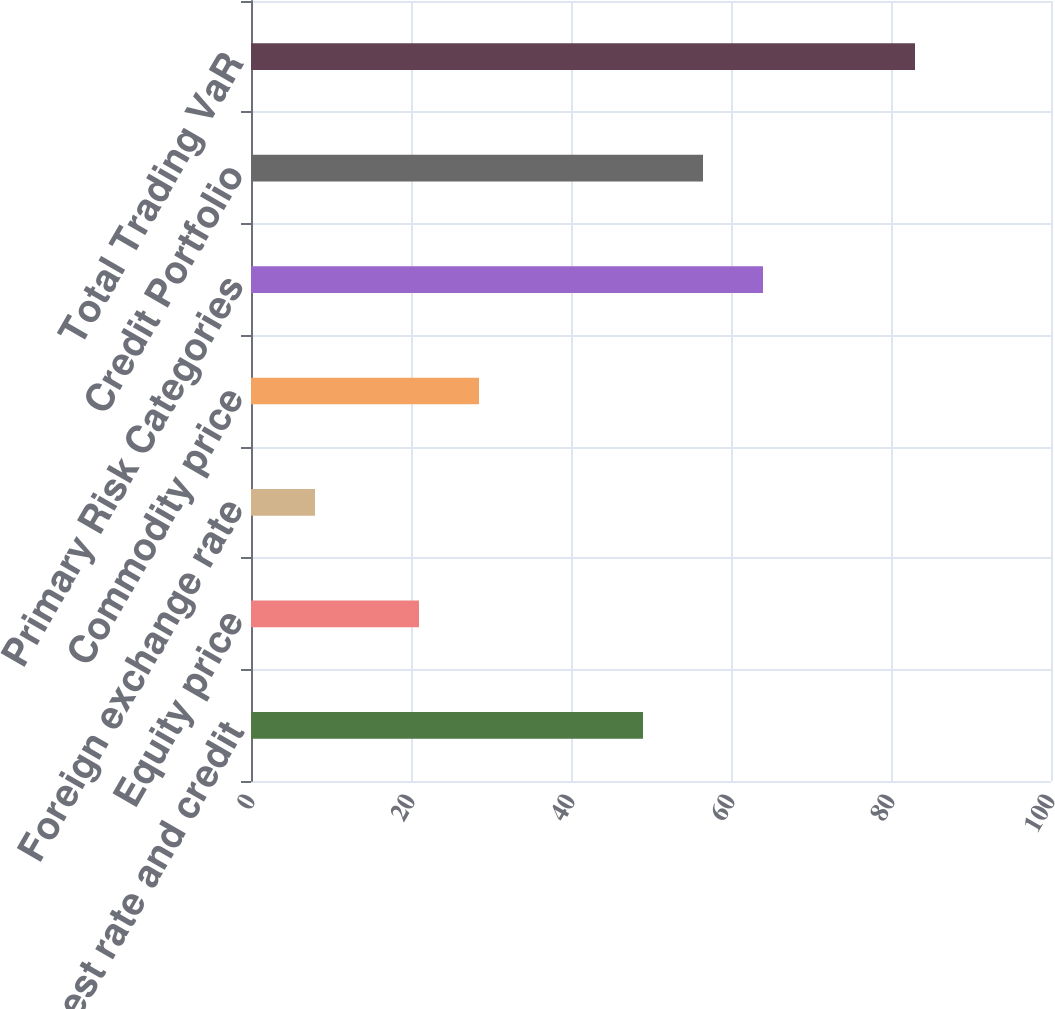<chart> <loc_0><loc_0><loc_500><loc_500><bar_chart><fcel>Interest rate and credit<fcel>Equity price<fcel>Foreign exchange rate<fcel>Commodity price<fcel>Primary Risk Categories<fcel>Credit Portfolio<fcel>Total Trading VaR<nl><fcel>49<fcel>21<fcel>8<fcel>28.5<fcel>64<fcel>56.5<fcel>83<nl></chart> 